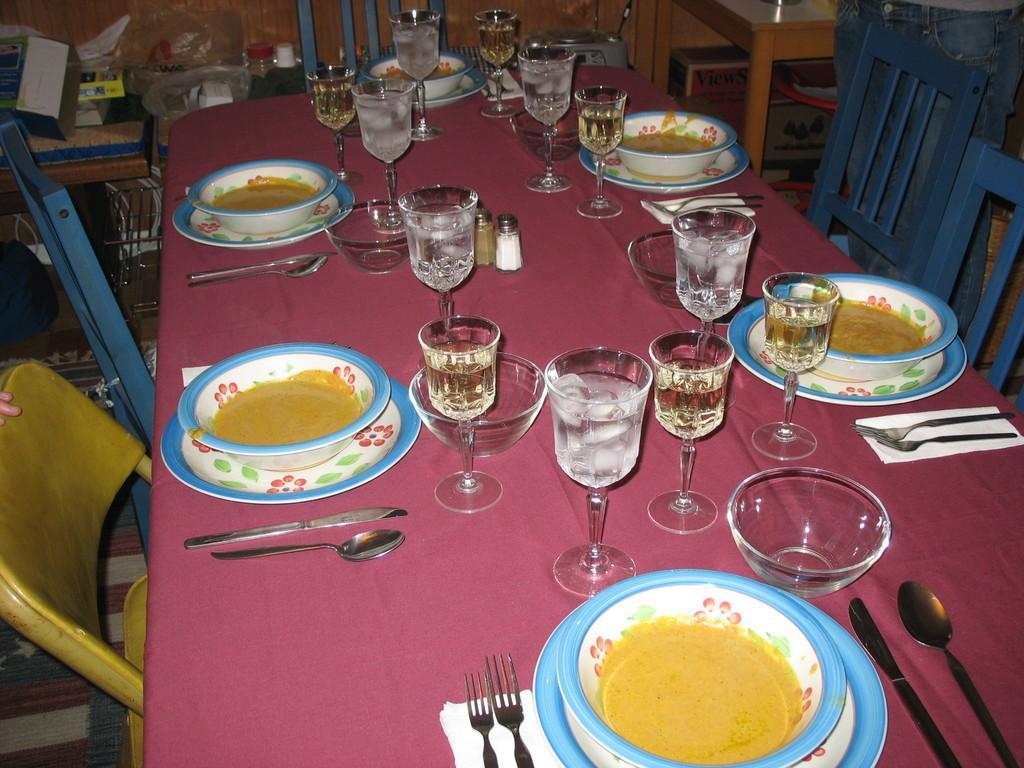Can you describe this image briefly? In this picture there is a dining table placed in front with some food in the bowl and many water glasses. Behind we can see the wooden chairs. 